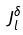Convert formula to latex. <formula><loc_0><loc_0><loc_500><loc_500>J _ { l } ^ { \delta }</formula> 